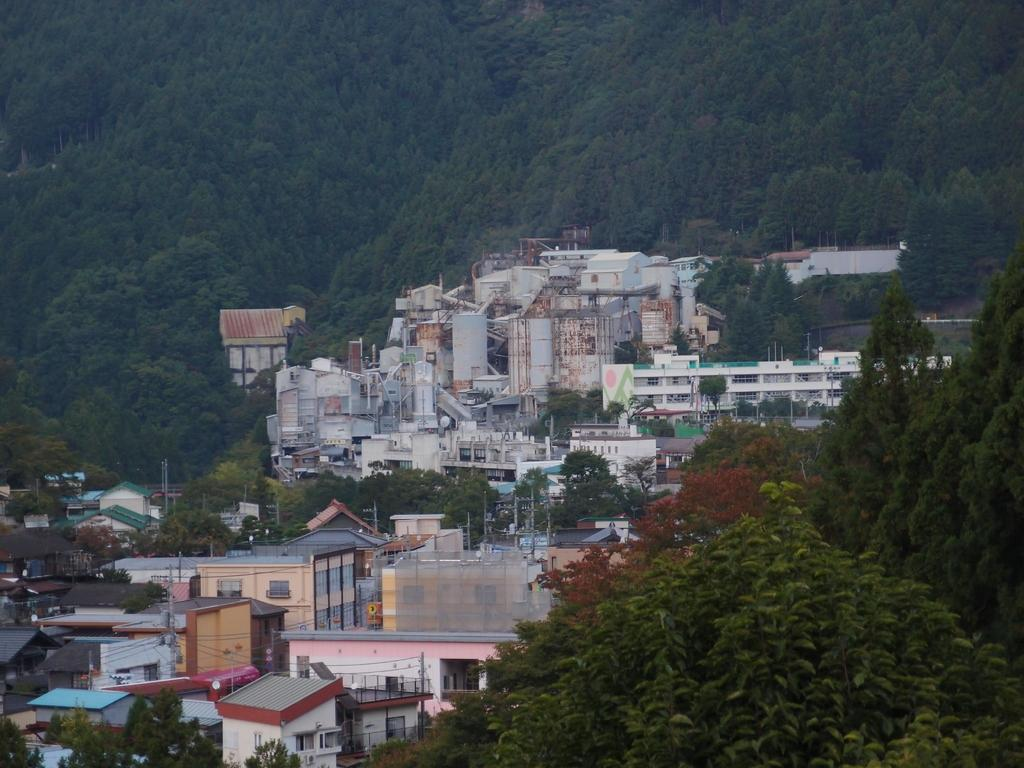What type of vegetation can be seen in the image? There are trees in the front and background of the image. What type of structures are present in the image? There are buildings in the center of the image. What historical event is being commemorated in the cemetery in the image? There is no cemetery present in the image; it features trees and buildings. 